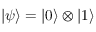Convert formula to latex. <formula><loc_0><loc_0><loc_500><loc_500>\left | \psi \right \rangle = \left | 0 \right \rangle \otimes \left | 1 \right \rangle</formula> 